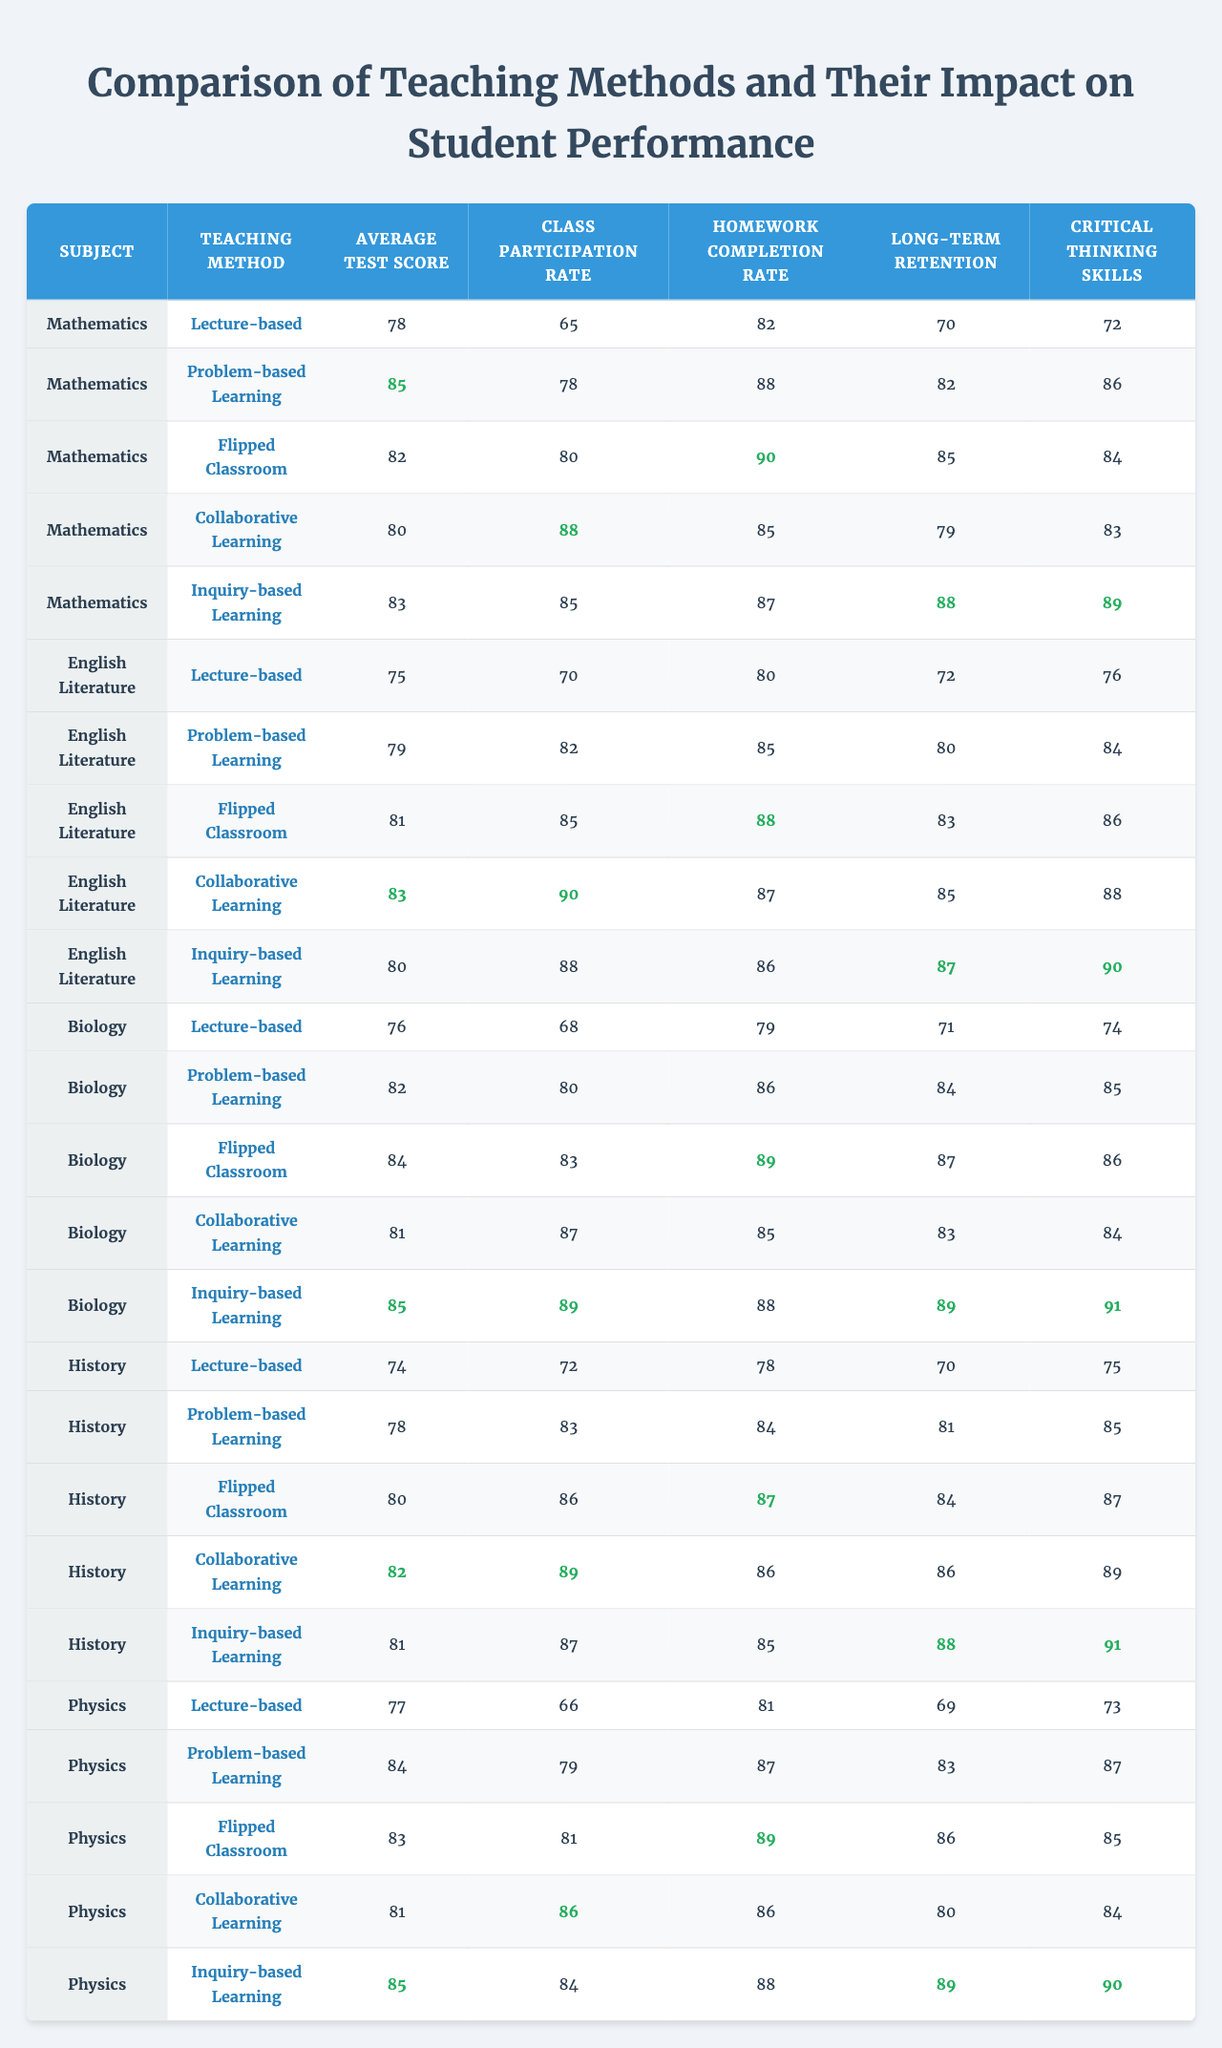What is the average test score for Inquiry-based Learning in Mathematics? The average test score for Inquiry-based Learning in Mathematics is listed in the table as 83.
Answer: 83 Which teaching method had the highest Class Participation Rate in Physics? In Physics, the teaching method with the highest Class Participation Rate is Inquiry-based Learning, which is 84.
Answer: 84 What is the difference in Average Test Scores between Collaborative Learning and Problem-based Learning in Biology? In Biology, Collaborative Learning has an Average Test Score of 81, and Problem-based Learning has an Average Test Score of 82. The difference is 82 - 81 = 1.
Answer: 1 In which subject did the Lecture-based method have the lowest Homework Completion Rate? The Lecture-based method had the lowest Homework Completion Rate in History, with a rate of 78.
Answer: History What are the average scores for Critical Thinking Skills across all subjects for the Flipped Classroom method? The average score for Critical Thinking Skills in the Flipped Classroom across all subjects is calculated as follows: (84 + 86 + 86 + 87 + 85) / 5 = 83.4.
Answer: 83.4 Which teaching method shows the best improvement in Long-term Retention in English Literature compared to the Lecture-based method? In English Literature, the Long-term Retention for the Lecture-based method is 72, while the Inquiry-based Learning has a Long-term Retention of 87, showing an improvement of 87 - 72 = 15.
Answer: 15 Is it true that the average test score for Collaborative Learning is higher than that for Lecture-based in all subjects? No, this statement is false. In Mathematics, the Lecture-based method has a higher score (78) than Collaborative Learning (80).
Answer: No Which teaching method consistently performs the best in all performance metrics across the subjects? Inquiry-based Learning consistently shows the highest scores in most metrics across subjects, such as Average Test Scores and Long-term Retention, making it the best-performing method overall.
Answer: Inquiry-based Learning What is the total of Homework Completion Rates for all subjects using the Problem-based Learning method? The total Homework Completion Rate for Problem-based Learning is calculated as 88 (Mathematics) + 85 (English Literature) + 86 (Biology) + 84 (History) + 87 (Physics) = 430.
Answer: 430 Which subject had the closest Average Test Score between the Lecture-based and Flipped Classroom methods? In Biology, the Average Test Scores are closest, with Lecture-based at 76 and Flipped Classroom at 84, having a difference of 8.
Answer: Biology 